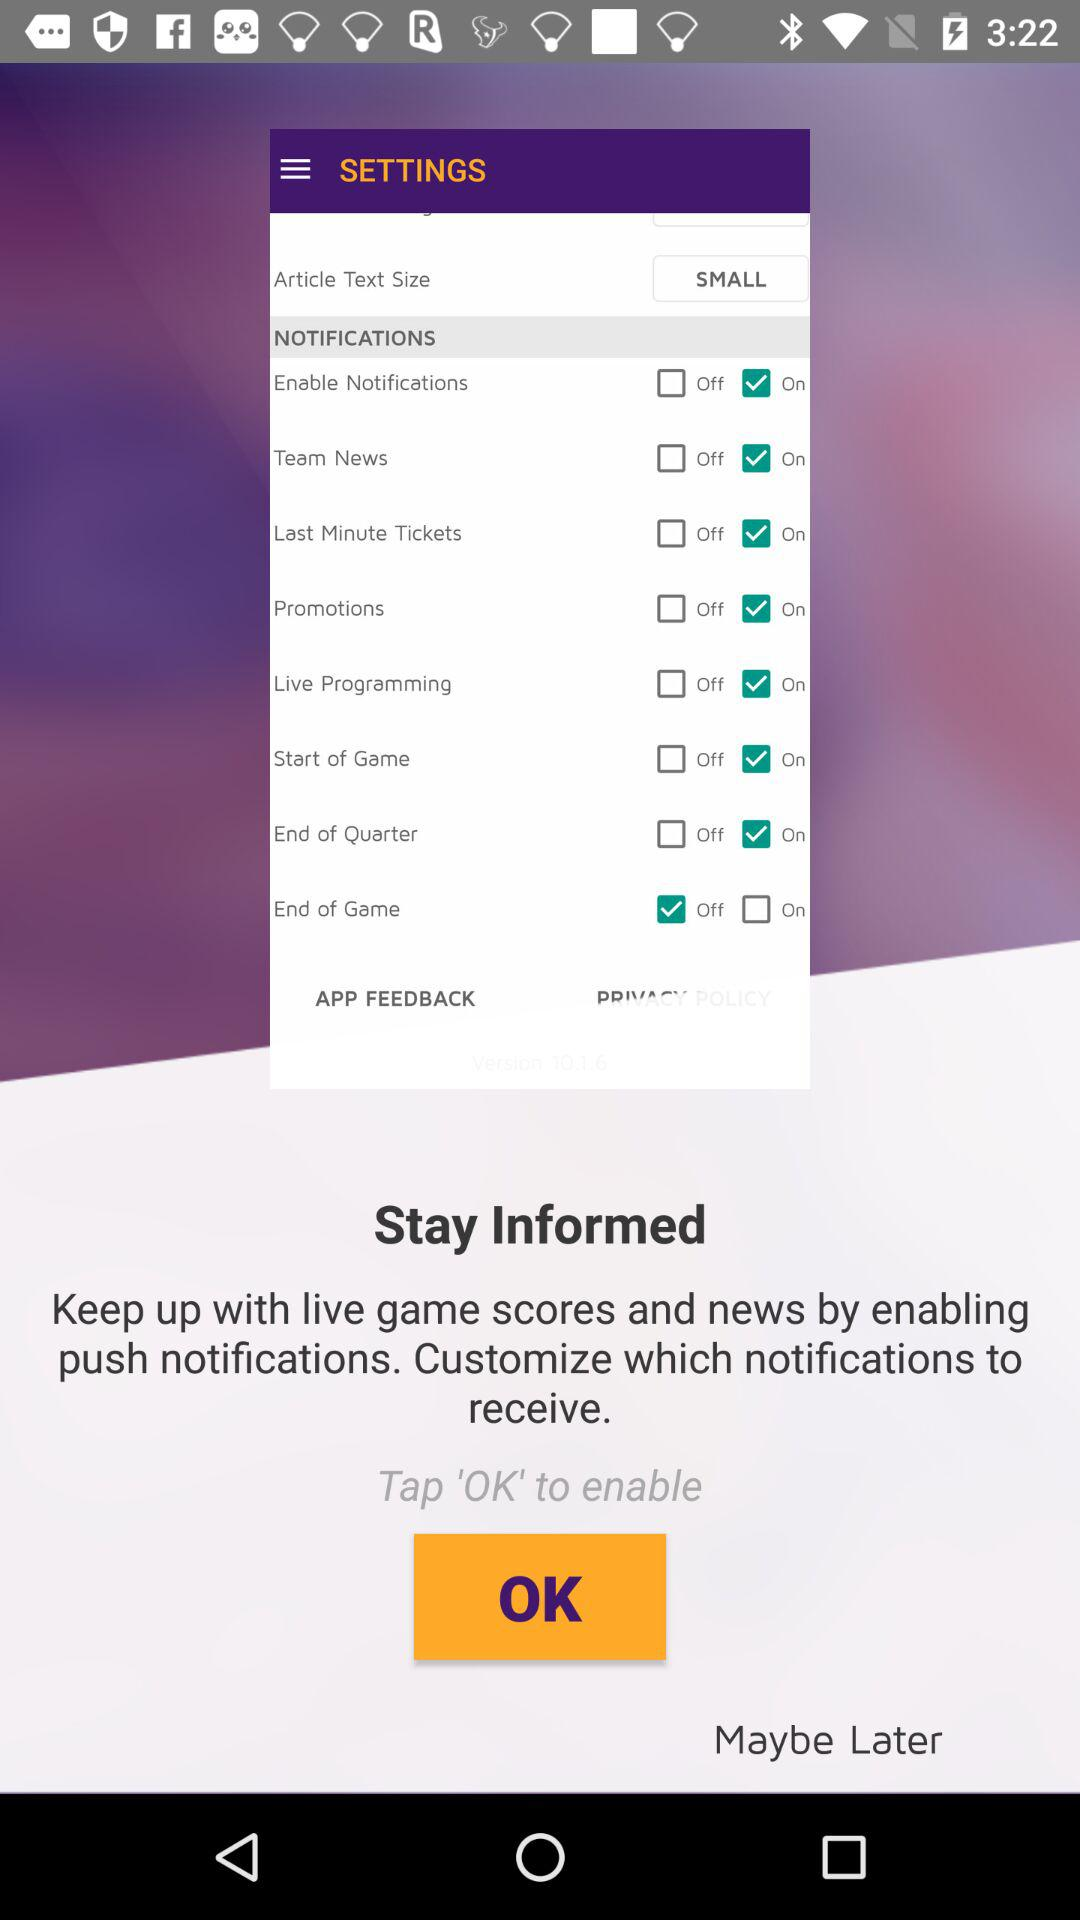What is the status of the "Promotions" notification? The status is on. 